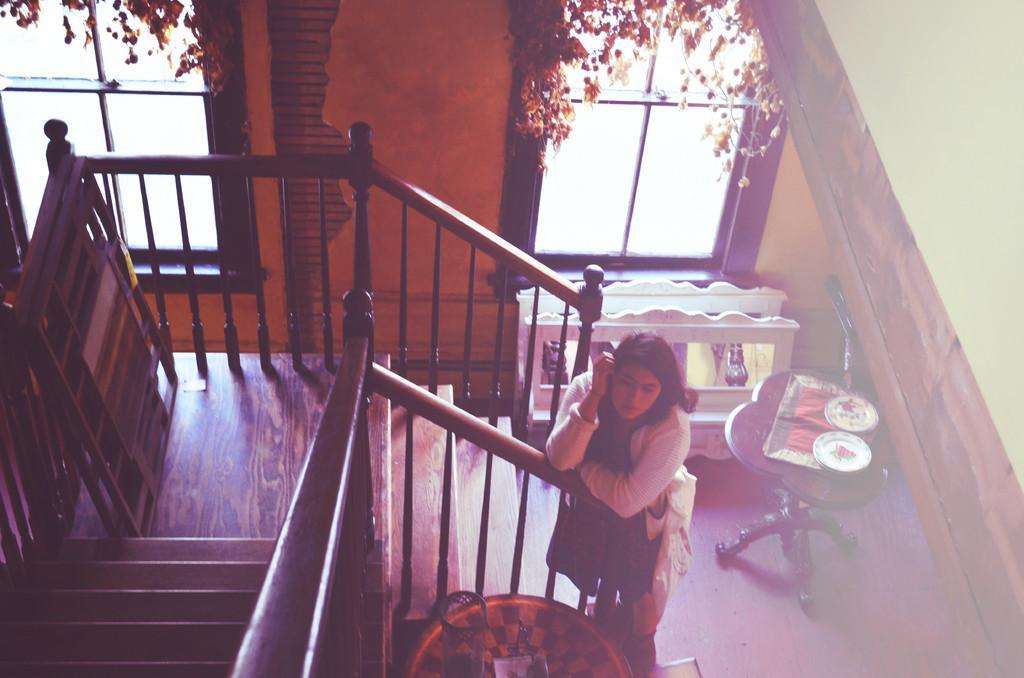In one or two sentences, can you explain what this image depicts? In this image I can see there is a lady standing beside the stairs, at the back there are so many objects also there are windows in the middle of the wall. 